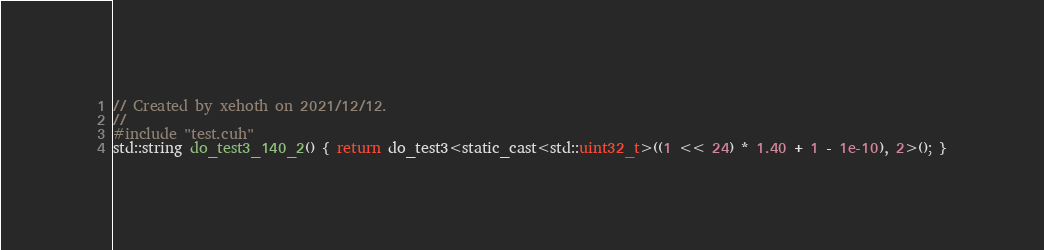<code> <loc_0><loc_0><loc_500><loc_500><_Cuda_>// Created by xehoth on 2021/12/12.
//
#include "test.cuh"
std::string do_test3_140_2() { return do_test3<static_cast<std::uint32_t>((1 << 24) * 1.40 + 1 - 1e-10), 2>(); }
</code> 